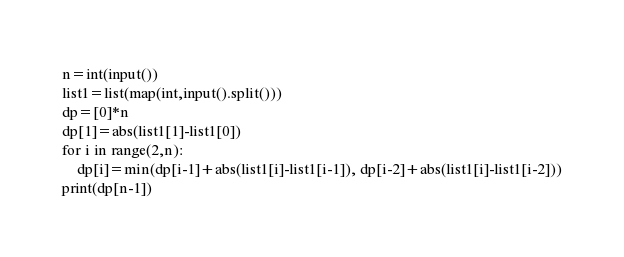<code> <loc_0><loc_0><loc_500><loc_500><_Python_>n=int(input())
list1=list(map(int,input().split()))
dp=[0]*n
dp[1]=abs(list1[1]-list1[0])
for i in range(2,n):
    dp[i]=min(dp[i-1]+abs(list1[i]-list1[i-1]), dp[i-2]+abs(list1[i]-list1[i-2]))
print(dp[n-1])
</code> 